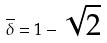Convert formula to latex. <formula><loc_0><loc_0><loc_500><loc_500>\overline { \delta } = 1 - \sqrt { 2 }</formula> 